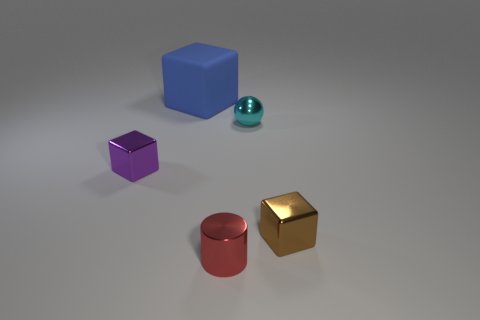Add 3 small green metallic things. How many objects exist? 8 Subtract all cylinders. How many objects are left? 4 Subtract all yellow rubber balls. Subtract all tiny cyan things. How many objects are left? 4 Add 3 big blocks. How many big blocks are left? 4 Add 3 purple things. How many purple things exist? 4 Subtract 0 red blocks. How many objects are left? 5 